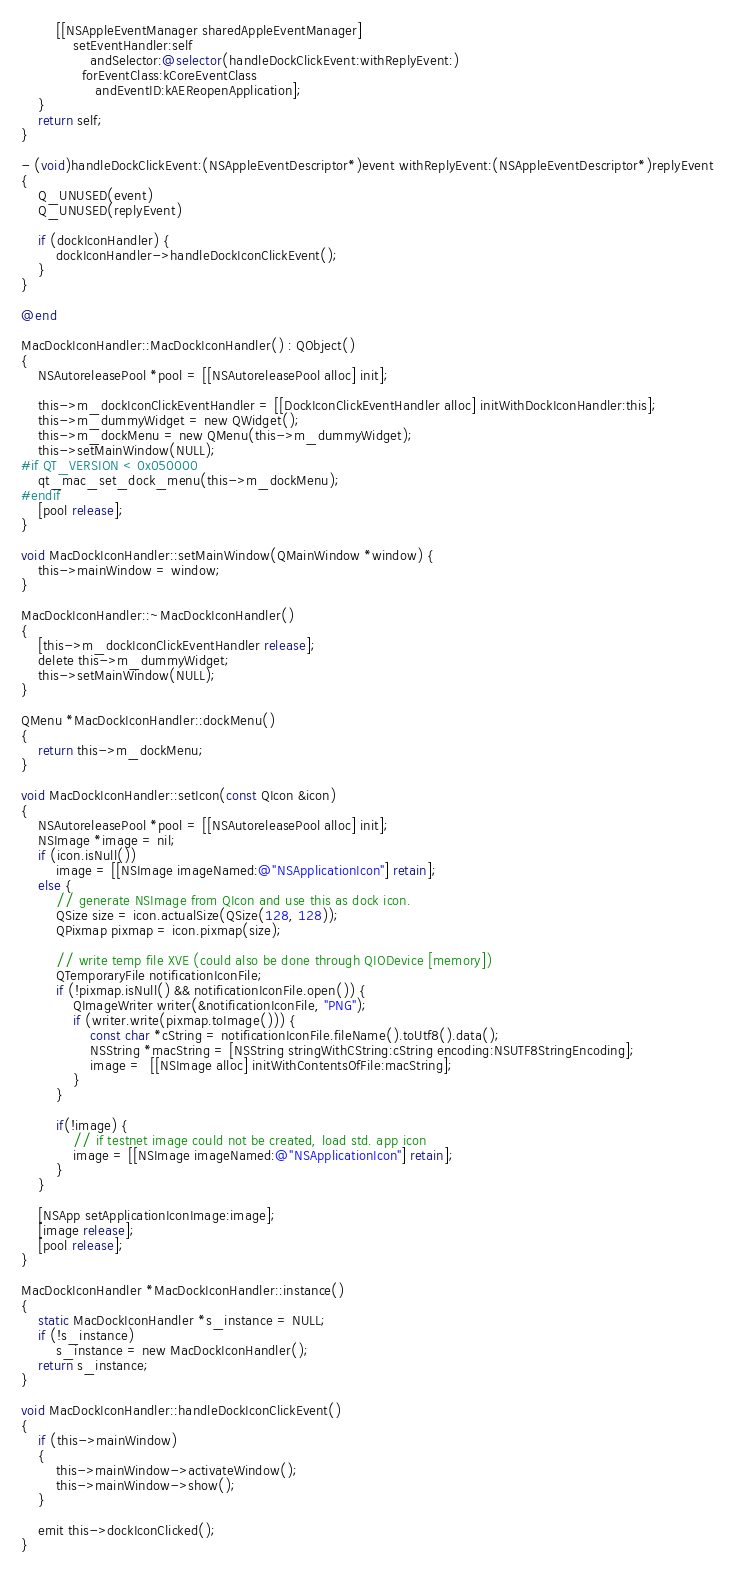Convert code to text. <code><loc_0><loc_0><loc_500><loc_500><_ObjectiveC_>
        [[NSAppleEventManager sharedAppleEventManager]
            setEventHandler:self
                andSelector:@selector(handleDockClickEvent:withReplyEvent:)
              forEventClass:kCoreEventClass
                 andEventID:kAEReopenApplication];
    }
    return self;
}

- (void)handleDockClickEvent:(NSAppleEventDescriptor*)event withReplyEvent:(NSAppleEventDescriptor*)replyEvent
{
    Q_UNUSED(event)
    Q_UNUSED(replyEvent)

    if (dockIconHandler) {
        dockIconHandler->handleDockIconClickEvent();
    }
}

@end

MacDockIconHandler::MacDockIconHandler() : QObject()
{
    NSAutoreleasePool *pool = [[NSAutoreleasePool alloc] init];

    this->m_dockIconClickEventHandler = [[DockIconClickEventHandler alloc] initWithDockIconHandler:this];
    this->m_dummyWidget = new QWidget();
    this->m_dockMenu = new QMenu(this->m_dummyWidget);
    this->setMainWindow(NULL);
#if QT_VERSION < 0x050000
    qt_mac_set_dock_menu(this->m_dockMenu);
#endif
    [pool release];
}

void MacDockIconHandler::setMainWindow(QMainWindow *window) {
    this->mainWindow = window;
}

MacDockIconHandler::~MacDockIconHandler()
{
    [this->m_dockIconClickEventHandler release];
    delete this->m_dummyWidget;
    this->setMainWindow(NULL);
}

QMenu *MacDockIconHandler::dockMenu()
{
    return this->m_dockMenu;
}

void MacDockIconHandler::setIcon(const QIcon &icon)
{
    NSAutoreleasePool *pool = [[NSAutoreleasePool alloc] init];
    NSImage *image = nil;
    if (icon.isNull())
        image = [[NSImage imageNamed:@"NSApplicationIcon"] retain];
    else {
        // generate NSImage from QIcon and use this as dock icon.
        QSize size = icon.actualSize(QSize(128, 128));
        QPixmap pixmap = icon.pixmap(size);

        // write temp file XVE (could also be done through QIODevice [memory])
        QTemporaryFile notificationIconFile;
        if (!pixmap.isNull() && notificationIconFile.open()) {
            QImageWriter writer(&notificationIconFile, "PNG");
            if (writer.write(pixmap.toImage())) {
                const char *cString = notificationIconFile.fileName().toUtf8().data();
                NSString *macString = [NSString stringWithCString:cString encoding:NSUTF8StringEncoding];
                image =  [[NSImage alloc] initWithContentsOfFile:macString];
            }
        }

        if(!image) {
            // if testnet image could not be created, load std. app icon
            image = [[NSImage imageNamed:@"NSApplicationIcon"] retain];
        }
    }

    [NSApp setApplicationIconImage:image];
    [image release];
    [pool release];
}

MacDockIconHandler *MacDockIconHandler::instance()
{
    static MacDockIconHandler *s_instance = NULL;
    if (!s_instance)
        s_instance = new MacDockIconHandler();
    return s_instance;
}

void MacDockIconHandler::handleDockIconClickEvent()
{
    if (this->mainWindow)
    {
        this->mainWindow->activateWindow();
        this->mainWindow->show();
    }

    emit this->dockIconClicked();
}
</code> 